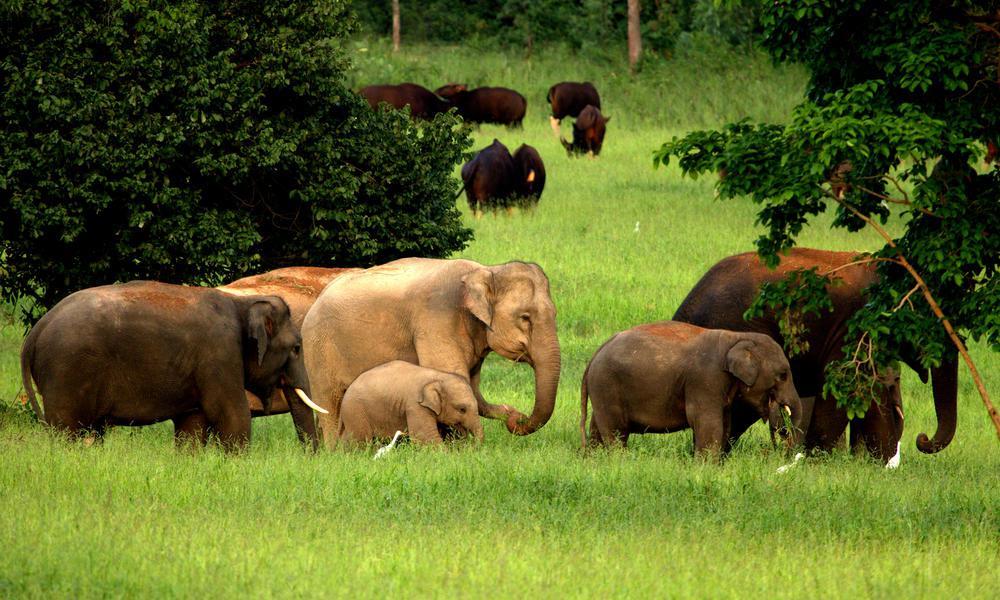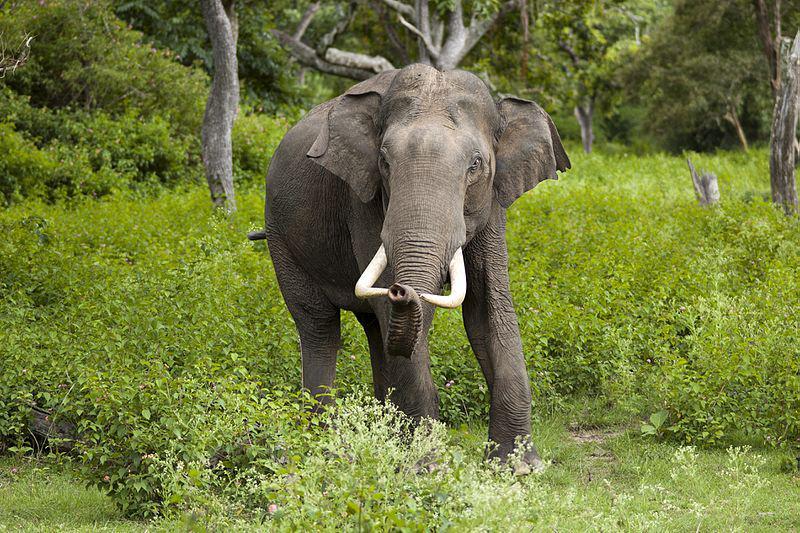The first image is the image on the left, the second image is the image on the right. Assess this claim about the two images: "There are no more than 4 elephants in the image pair". Correct or not? Answer yes or no. No. The first image is the image on the left, the second image is the image on the right. Evaluate the accuracy of this statement regarding the images: "There are at least six elephants.". Is it true? Answer yes or no. Yes. 